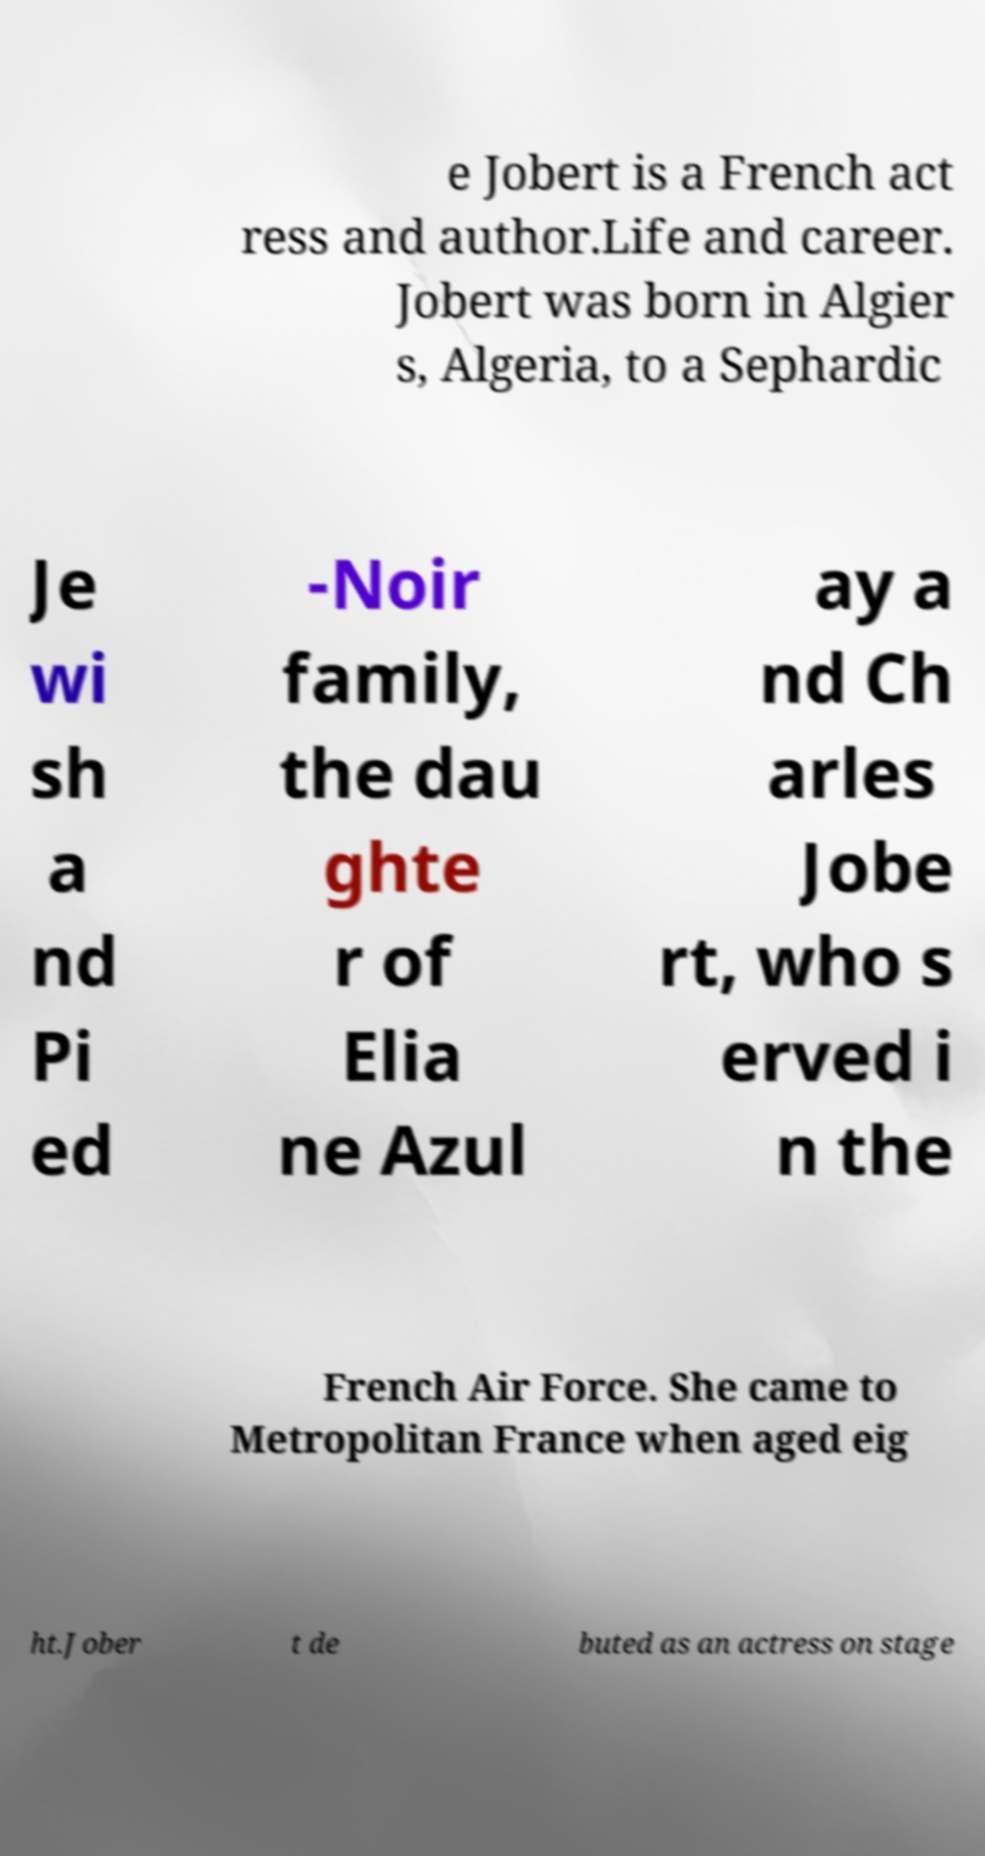There's text embedded in this image that I need extracted. Can you transcribe it verbatim? e Jobert is a French act ress and author.Life and career. Jobert was born in Algier s, Algeria, to a Sephardic Je wi sh a nd Pi ed -Noir family, the dau ghte r of Elia ne Azul ay a nd Ch arles Jobe rt, who s erved i n the French Air Force. She came to Metropolitan France when aged eig ht.Jober t de buted as an actress on stage 